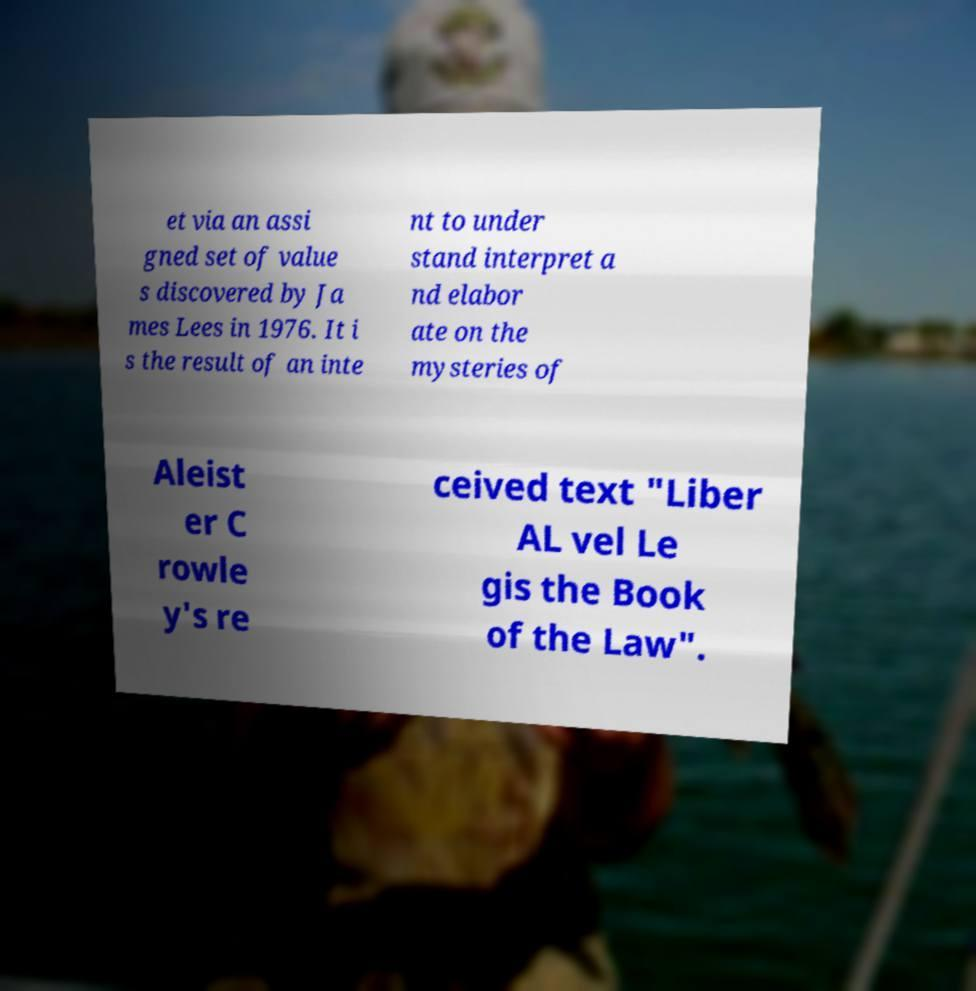Please identify and transcribe the text found in this image. et via an assi gned set of value s discovered by Ja mes Lees in 1976. It i s the result of an inte nt to under stand interpret a nd elabor ate on the mysteries of Aleist er C rowle y's re ceived text "Liber AL vel Le gis the Book of the Law". 